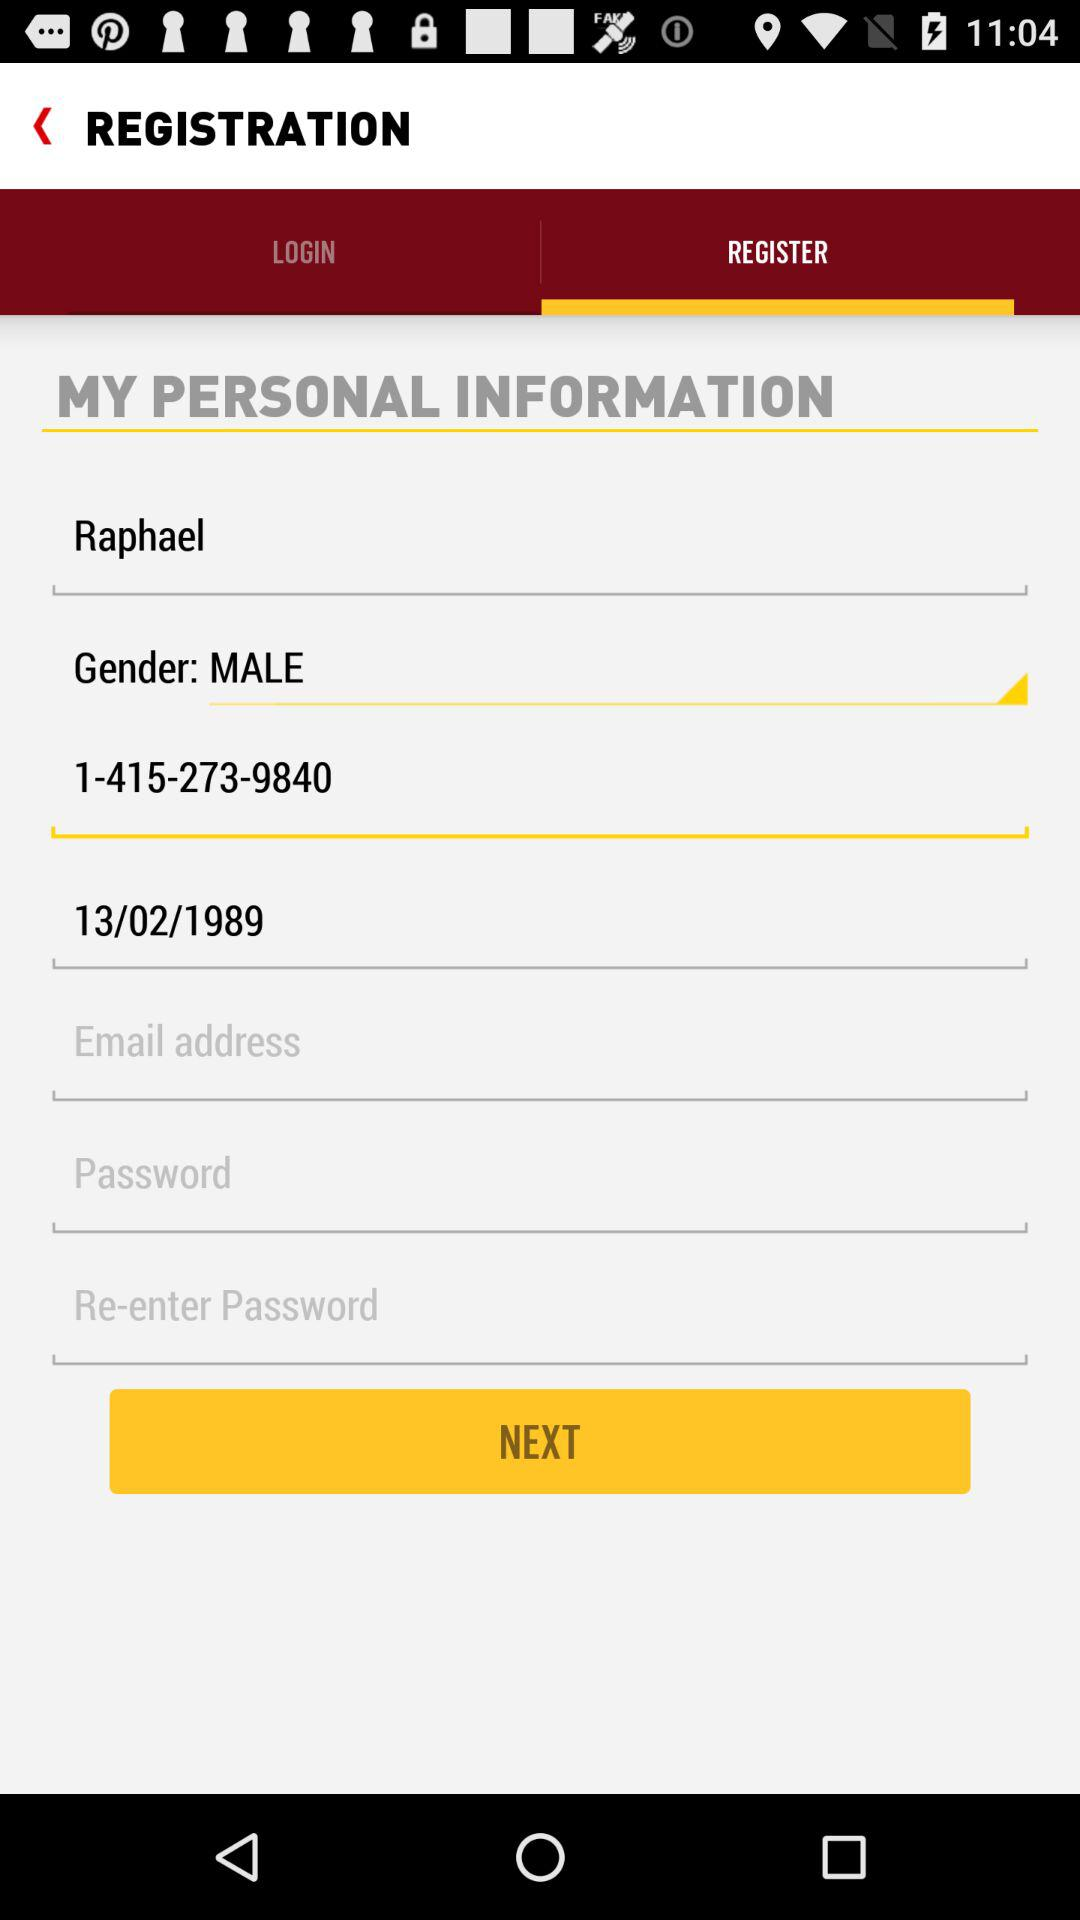What is the given phone number? The given phone number is 1-415-273-9840. 